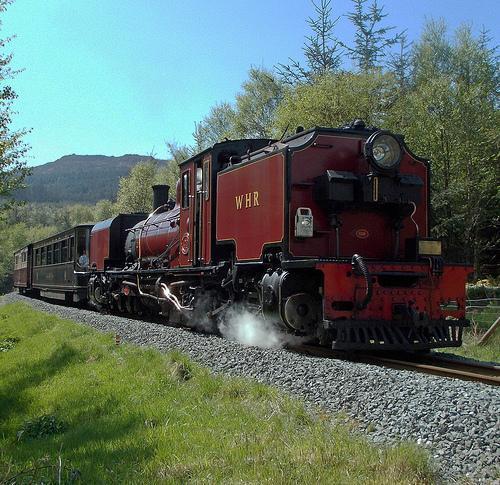How many trains are visible?
Give a very brief answer. 1. 